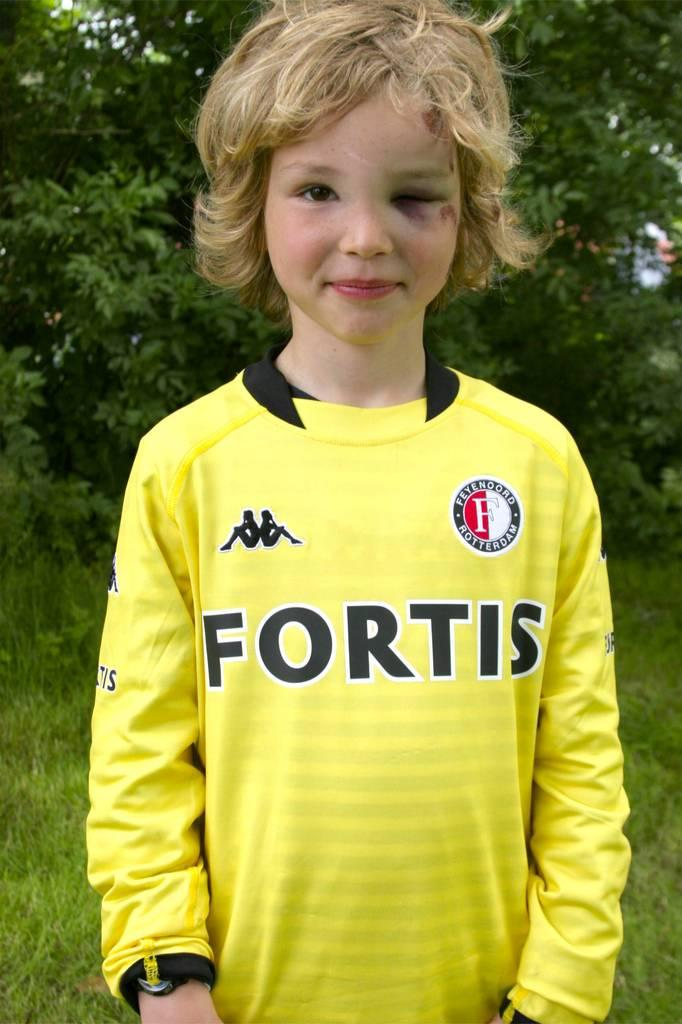<image>
Create a compact narrative representing the image presented. A child with a black eye wearing a yellow shirt reading Fortis. 